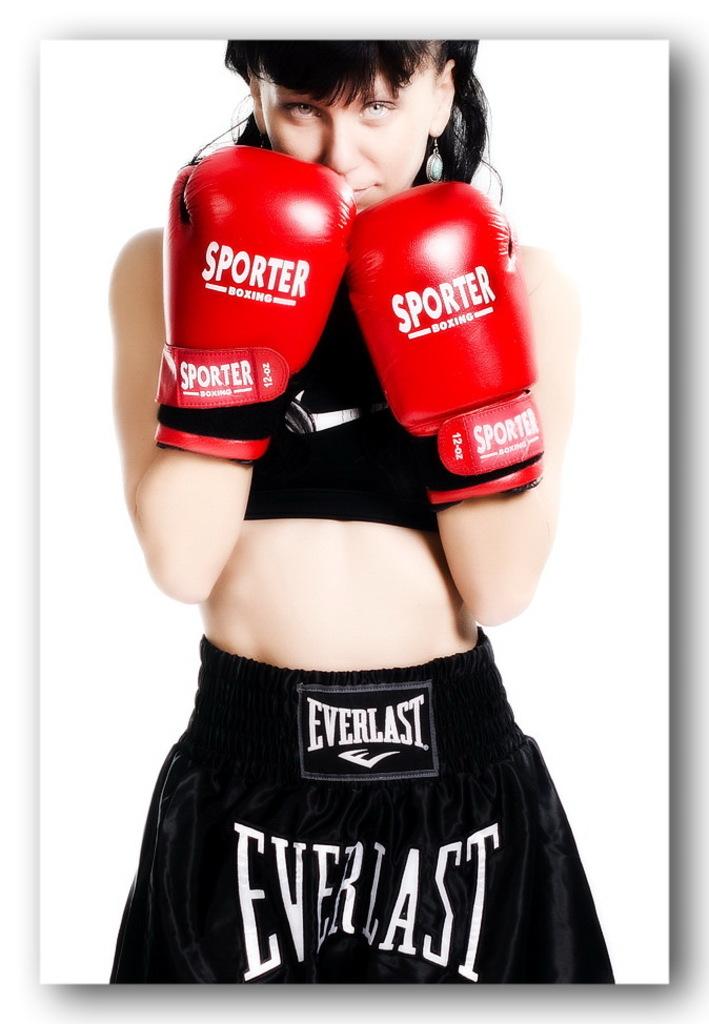Yes everlast sponsor?
Offer a very short reply. Yes. Is this boxer sponsored by everlast?
Your response must be concise. Yes. 